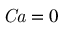Convert formula to latex. <formula><loc_0><loc_0><loc_500><loc_500>C a = 0</formula> 